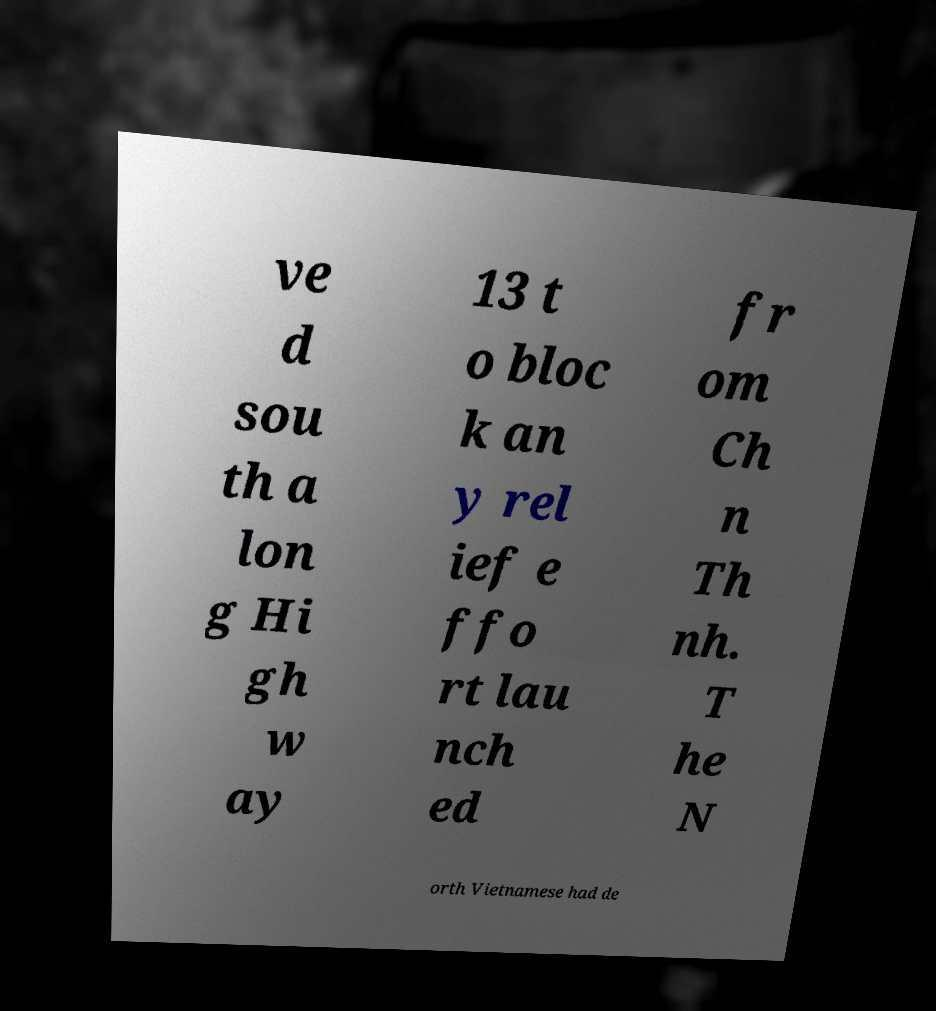What messages or text are displayed in this image? I need them in a readable, typed format. ve d sou th a lon g Hi gh w ay 13 t o bloc k an y rel ief e ffo rt lau nch ed fr om Ch n Th nh. T he N orth Vietnamese had de 